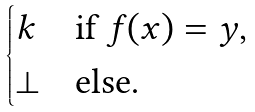Convert formula to latex. <formula><loc_0><loc_0><loc_500><loc_500>\begin{cases} k & \text {if $f(x)=y$,} \\ \bot & \text {else.} \end{cases}</formula> 